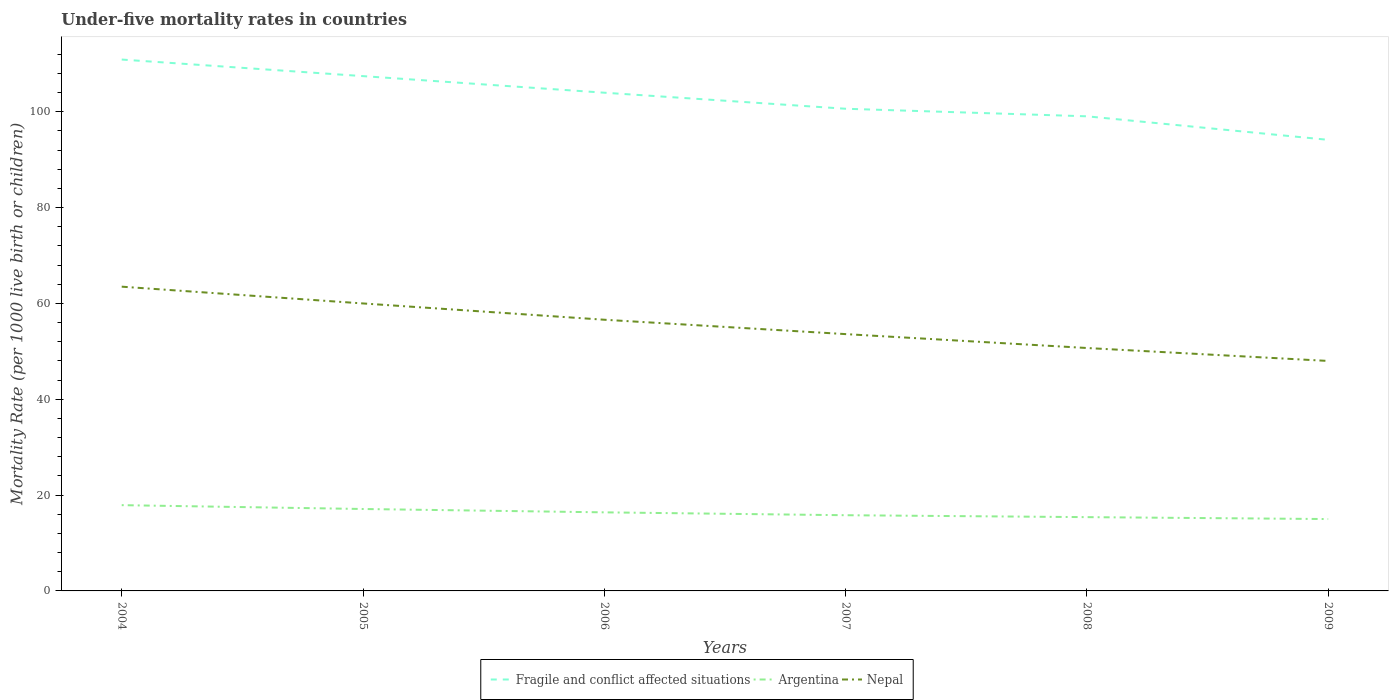How many different coloured lines are there?
Provide a succinct answer. 3. Does the line corresponding to Nepal intersect with the line corresponding to Fragile and conflict affected situations?
Provide a short and direct response. No. Is the number of lines equal to the number of legend labels?
Offer a very short reply. Yes. In which year was the under-five mortality rate in Argentina maximum?
Your response must be concise. 2009. What is the total under-five mortality rate in Argentina in the graph?
Keep it short and to the point. 1.7. What is the difference between the highest and the second highest under-five mortality rate in Fragile and conflict affected situations?
Offer a very short reply. 16.76. What is the difference between the highest and the lowest under-five mortality rate in Argentina?
Provide a succinct answer. 3. Is the under-five mortality rate in Fragile and conflict affected situations strictly greater than the under-five mortality rate in Nepal over the years?
Provide a short and direct response. No. What is the difference between two consecutive major ticks on the Y-axis?
Your answer should be compact. 20. Are the values on the major ticks of Y-axis written in scientific E-notation?
Keep it short and to the point. No. Does the graph contain any zero values?
Ensure brevity in your answer.  No. Does the graph contain grids?
Keep it short and to the point. No. Where does the legend appear in the graph?
Your response must be concise. Bottom center. How many legend labels are there?
Provide a succinct answer. 3. How are the legend labels stacked?
Your response must be concise. Horizontal. What is the title of the graph?
Offer a terse response. Under-five mortality rates in countries. What is the label or title of the X-axis?
Offer a terse response. Years. What is the label or title of the Y-axis?
Your response must be concise. Mortality Rate (per 1000 live birth or children). What is the Mortality Rate (per 1000 live birth or children) in Fragile and conflict affected situations in 2004?
Provide a succinct answer. 110.9. What is the Mortality Rate (per 1000 live birth or children) in Nepal in 2004?
Your answer should be very brief. 63.5. What is the Mortality Rate (per 1000 live birth or children) of Fragile and conflict affected situations in 2005?
Provide a short and direct response. 107.44. What is the Mortality Rate (per 1000 live birth or children) in Argentina in 2005?
Offer a terse response. 17.1. What is the Mortality Rate (per 1000 live birth or children) of Fragile and conflict affected situations in 2006?
Your answer should be very brief. 103.98. What is the Mortality Rate (per 1000 live birth or children) of Argentina in 2006?
Your answer should be compact. 16.4. What is the Mortality Rate (per 1000 live birth or children) of Nepal in 2006?
Keep it short and to the point. 56.6. What is the Mortality Rate (per 1000 live birth or children) of Fragile and conflict affected situations in 2007?
Provide a succinct answer. 100.64. What is the Mortality Rate (per 1000 live birth or children) of Argentina in 2007?
Provide a succinct answer. 15.8. What is the Mortality Rate (per 1000 live birth or children) of Nepal in 2007?
Offer a terse response. 53.6. What is the Mortality Rate (per 1000 live birth or children) of Fragile and conflict affected situations in 2008?
Provide a succinct answer. 99.06. What is the Mortality Rate (per 1000 live birth or children) of Argentina in 2008?
Your answer should be very brief. 15.4. What is the Mortality Rate (per 1000 live birth or children) in Nepal in 2008?
Offer a terse response. 50.7. What is the Mortality Rate (per 1000 live birth or children) in Fragile and conflict affected situations in 2009?
Your answer should be very brief. 94.15. What is the Mortality Rate (per 1000 live birth or children) in Nepal in 2009?
Provide a succinct answer. 48. Across all years, what is the maximum Mortality Rate (per 1000 live birth or children) in Fragile and conflict affected situations?
Your answer should be very brief. 110.9. Across all years, what is the maximum Mortality Rate (per 1000 live birth or children) in Nepal?
Give a very brief answer. 63.5. Across all years, what is the minimum Mortality Rate (per 1000 live birth or children) in Fragile and conflict affected situations?
Your answer should be compact. 94.15. What is the total Mortality Rate (per 1000 live birth or children) of Fragile and conflict affected situations in the graph?
Keep it short and to the point. 616.17. What is the total Mortality Rate (per 1000 live birth or children) of Argentina in the graph?
Ensure brevity in your answer.  97.6. What is the total Mortality Rate (per 1000 live birth or children) of Nepal in the graph?
Provide a short and direct response. 332.4. What is the difference between the Mortality Rate (per 1000 live birth or children) in Fragile and conflict affected situations in 2004 and that in 2005?
Offer a very short reply. 3.46. What is the difference between the Mortality Rate (per 1000 live birth or children) of Fragile and conflict affected situations in 2004 and that in 2006?
Keep it short and to the point. 6.92. What is the difference between the Mortality Rate (per 1000 live birth or children) of Argentina in 2004 and that in 2006?
Keep it short and to the point. 1.5. What is the difference between the Mortality Rate (per 1000 live birth or children) of Fragile and conflict affected situations in 2004 and that in 2007?
Keep it short and to the point. 10.27. What is the difference between the Mortality Rate (per 1000 live birth or children) of Fragile and conflict affected situations in 2004 and that in 2008?
Offer a very short reply. 11.85. What is the difference between the Mortality Rate (per 1000 live birth or children) in Argentina in 2004 and that in 2008?
Give a very brief answer. 2.5. What is the difference between the Mortality Rate (per 1000 live birth or children) of Nepal in 2004 and that in 2008?
Make the answer very short. 12.8. What is the difference between the Mortality Rate (per 1000 live birth or children) in Fragile and conflict affected situations in 2004 and that in 2009?
Offer a very short reply. 16.76. What is the difference between the Mortality Rate (per 1000 live birth or children) in Argentina in 2004 and that in 2009?
Give a very brief answer. 2.9. What is the difference between the Mortality Rate (per 1000 live birth or children) of Fragile and conflict affected situations in 2005 and that in 2006?
Your answer should be very brief. 3.46. What is the difference between the Mortality Rate (per 1000 live birth or children) of Argentina in 2005 and that in 2006?
Offer a terse response. 0.7. What is the difference between the Mortality Rate (per 1000 live birth or children) in Fragile and conflict affected situations in 2005 and that in 2007?
Offer a terse response. 6.81. What is the difference between the Mortality Rate (per 1000 live birth or children) in Fragile and conflict affected situations in 2005 and that in 2008?
Your response must be concise. 8.39. What is the difference between the Mortality Rate (per 1000 live birth or children) of Nepal in 2005 and that in 2008?
Offer a terse response. 9.3. What is the difference between the Mortality Rate (per 1000 live birth or children) in Fragile and conflict affected situations in 2005 and that in 2009?
Provide a succinct answer. 13.3. What is the difference between the Mortality Rate (per 1000 live birth or children) in Argentina in 2005 and that in 2009?
Provide a succinct answer. 2.1. What is the difference between the Mortality Rate (per 1000 live birth or children) in Nepal in 2005 and that in 2009?
Give a very brief answer. 12. What is the difference between the Mortality Rate (per 1000 live birth or children) in Fragile and conflict affected situations in 2006 and that in 2007?
Provide a succinct answer. 3.35. What is the difference between the Mortality Rate (per 1000 live birth or children) in Argentina in 2006 and that in 2007?
Offer a very short reply. 0.6. What is the difference between the Mortality Rate (per 1000 live birth or children) in Nepal in 2006 and that in 2007?
Your response must be concise. 3. What is the difference between the Mortality Rate (per 1000 live birth or children) of Fragile and conflict affected situations in 2006 and that in 2008?
Your answer should be compact. 4.93. What is the difference between the Mortality Rate (per 1000 live birth or children) of Fragile and conflict affected situations in 2006 and that in 2009?
Offer a terse response. 9.84. What is the difference between the Mortality Rate (per 1000 live birth or children) of Nepal in 2006 and that in 2009?
Your answer should be very brief. 8.6. What is the difference between the Mortality Rate (per 1000 live birth or children) in Fragile and conflict affected situations in 2007 and that in 2008?
Give a very brief answer. 1.58. What is the difference between the Mortality Rate (per 1000 live birth or children) of Nepal in 2007 and that in 2008?
Provide a short and direct response. 2.9. What is the difference between the Mortality Rate (per 1000 live birth or children) in Fragile and conflict affected situations in 2007 and that in 2009?
Offer a terse response. 6.49. What is the difference between the Mortality Rate (per 1000 live birth or children) of Argentina in 2007 and that in 2009?
Your response must be concise. 0.8. What is the difference between the Mortality Rate (per 1000 live birth or children) in Fragile and conflict affected situations in 2008 and that in 2009?
Offer a terse response. 4.91. What is the difference between the Mortality Rate (per 1000 live birth or children) of Fragile and conflict affected situations in 2004 and the Mortality Rate (per 1000 live birth or children) of Argentina in 2005?
Your response must be concise. 93.8. What is the difference between the Mortality Rate (per 1000 live birth or children) in Fragile and conflict affected situations in 2004 and the Mortality Rate (per 1000 live birth or children) in Nepal in 2005?
Keep it short and to the point. 50.9. What is the difference between the Mortality Rate (per 1000 live birth or children) of Argentina in 2004 and the Mortality Rate (per 1000 live birth or children) of Nepal in 2005?
Your answer should be compact. -42.1. What is the difference between the Mortality Rate (per 1000 live birth or children) of Fragile and conflict affected situations in 2004 and the Mortality Rate (per 1000 live birth or children) of Argentina in 2006?
Keep it short and to the point. 94.5. What is the difference between the Mortality Rate (per 1000 live birth or children) of Fragile and conflict affected situations in 2004 and the Mortality Rate (per 1000 live birth or children) of Nepal in 2006?
Provide a short and direct response. 54.3. What is the difference between the Mortality Rate (per 1000 live birth or children) of Argentina in 2004 and the Mortality Rate (per 1000 live birth or children) of Nepal in 2006?
Make the answer very short. -38.7. What is the difference between the Mortality Rate (per 1000 live birth or children) in Fragile and conflict affected situations in 2004 and the Mortality Rate (per 1000 live birth or children) in Argentina in 2007?
Offer a terse response. 95.1. What is the difference between the Mortality Rate (per 1000 live birth or children) in Fragile and conflict affected situations in 2004 and the Mortality Rate (per 1000 live birth or children) in Nepal in 2007?
Your answer should be very brief. 57.3. What is the difference between the Mortality Rate (per 1000 live birth or children) in Argentina in 2004 and the Mortality Rate (per 1000 live birth or children) in Nepal in 2007?
Ensure brevity in your answer.  -35.7. What is the difference between the Mortality Rate (per 1000 live birth or children) in Fragile and conflict affected situations in 2004 and the Mortality Rate (per 1000 live birth or children) in Argentina in 2008?
Make the answer very short. 95.5. What is the difference between the Mortality Rate (per 1000 live birth or children) in Fragile and conflict affected situations in 2004 and the Mortality Rate (per 1000 live birth or children) in Nepal in 2008?
Make the answer very short. 60.2. What is the difference between the Mortality Rate (per 1000 live birth or children) of Argentina in 2004 and the Mortality Rate (per 1000 live birth or children) of Nepal in 2008?
Make the answer very short. -32.8. What is the difference between the Mortality Rate (per 1000 live birth or children) in Fragile and conflict affected situations in 2004 and the Mortality Rate (per 1000 live birth or children) in Argentina in 2009?
Your response must be concise. 95.9. What is the difference between the Mortality Rate (per 1000 live birth or children) of Fragile and conflict affected situations in 2004 and the Mortality Rate (per 1000 live birth or children) of Nepal in 2009?
Keep it short and to the point. 62.9. What is the difference between the Mortality Rate (per 1000 live birth or children) in Argentina in 2004 and the Mortality Rate (per 1000 live birth or children) in Nepal in 2009?
Give a very brief answer. -30.1. What is the difference between the Mortality Rate (per 1000 live birth or children) in Fragile and conflict affected situations in 2005 and the Mortality Rate (per 1000 live birth or children) in Argentina in 2006?
Make the answer very short. 91.04. What is the difference between the Mortality Rate (per 1000 live birth or children) of Fragile and conflict affected situations in 2005 and the Mortality Rate (per 1000 live birth or children) of Nepal in 2006?
Keep it short and to the point. 50.84. What is the difference between the Mortality Rate (per 1000 live birth or children) of Argentina in 2005 and the Mortality Rate (per 1000 live birth or children) of Nepal in 2006?
Your answer should be compact. -39.5. What is the difference between the Mortality Rate (per 1000 live birth or children) of Fragile and conflict affected situations in 2005 and the Mortality Rate (per 1000 live birth or children) of Argentina in 2007?
Provide a short and direct response. 91.64. What is the difference between the Mortality Rate (per 1000 live birth or children) of Fragile and conflict affected situations in 2005 and the Mortality Rate (per 1000 live birth or children) of Nepal in 2007?
Provide a succinct answer. 53.84. What is the difference between the Mortality Rate (per 1000 live birth or children) of Argentina in 2005 and the Mortality Rate (per 1000 live birth or children) of Nepal in 2007?
Keep it short and to the point. -36.5. What is the difference between the Mortality Rate (per 1000 live birth or children) of Fragile and conflict affected situations in 2005 and the Mortality Rate (per 1000 live birth or children) of Argentina in 2008?
Ensure brevity in your answer.  92.04. What is the difference between the Mortality Rate (per 1000 live birth or children) of Fragile and conflict affected situations in 2005 and the Mortality Rate (per 1000 live birth or children) of Nepal in 2008?
Ensure brevity in your answer.  56.74. What is the difference between the Mortality Rate (per 1000 live birth or children) of Argentina in 2005 and the Mortality Rate (per 1000 live birth or children) of Nepal in 2008?
Make the answer very short. -33.6. What is the difference between the Mortality Rate (per 1000 live birth or children) of Fragile and conflict affected situations in 2005 and the Mortality Rate (per 1000 live birth or children) of Argentina in 2009?
Your answer should be very brief. 92.44. What is the difference between the Mortality Rate (per 1000 live birth or children) of Fragile and conflict affected situations in 2005 and the Mortality Rate (per 1000 live birth or children) of Nepal in 2009?
Your answer should be very brief. 59.44. What is the difference between the Mortality Rate (per 1000 live birth or children) in Argentina in 2005 and the Mortality Rate (per 1000 live birth or children) in Nepal in 2009?
Offer a very short reply. -30.9. What is the difference between the Mortality Rate (per 1000 live birth or children) of Fragile and conflict affected situations in 2006 and the Mortality Rate (per 1000 live birth or children) of Argentina in 2007?
Ensure brevity in your answer.  88.18. What is the difference between the Mortality Rate (per 1000 live birth or children) in Fragile and conflict affected situations in 2006 and the Mortality Rate (per 1000 live birth or children) in Nepal in 2007?
Your answer should be compact. 50.38. What is the difference between the Mortality Rate (per 1000 live birth or children) in Argentina in 2006 and the Mortality Rate (per 1000 live birth or children) in Nepal in 2007?
Your answer should be compact. -37.2. What is the difference between the Mortality Rate (per 1000 live birth or children) in Fragile and conflict affected situations in 2006 and the Mortality Rate (per 1000 live birth or children) in Argentina in 2008?
Ensure brevity in your answer.  88.58. What is the difference between the Mortality Rate (per 1000 live birth or children) in Fragile and conflict affected situations in 2006 and the Mortality Rate (per 1000 live birth or children) in Nepal in 2008?
Give a very brief answer. 53.28. What is the difference between the Mortality Rate (per 1000 live birth or children) of Argentina in 2006 and the Mortality Rate (per 1000 live birth or children) of Nepal in 2008?
Offer a terse response. -34.3. What is the difference between the Mortality Rate (per 1000 live birth or children) of Fragile and conflict affected situations in 2006 and the Mortality Rate (per 1000 live birth or children) of Argentina in 2009?
Make the answer very short. 88.98. What is the difference between the Mortality Rate (per 1000 live birth or children) of Fragile and conflict affected situations in 2006 and the Mortality Rate (per 1000 live birth or children) of Nepal in 2009?
Offer a terse response. 55.98. What is the difference between the Mortality Rate (per 1000 live birth or children) in Argentina in 2006 and the Mortality Rate (per 1000 live birth or children) in Nepal in 2009?
Ensure brevity in your answer.  -31.6. What is the difference between the Mortality Rate (per 1000 live birth or children) of Fragile and conflict affected situations in 2007 and the Mortality Rate (per 1000 live birth or children) of Argentina in 2008?
Keep it short and to the point. 85.24. What is the difference between the Mortality Rate (per 1000 live birth or children) in Fragile and conflict affected situations in 2007 and the Mortality Rate (per 1000 live birth or children) in Nepal in 2008?
Make the answer very short. 49.94. What is the difference between the Mortality Rate (per 1000 live birth or children) of Argentina in 2007 and the Mortality Rate (per 1000 live birth or children) of Nepal in 2008?
Your answer should be very brief. -34.9. What is the difference between the Mortality Rate (per 1000 live birth or children) in Fragile and conflict affected situations in 2007 and the Mortality Rate (per 1000 live birth or children) in Argentina in 2009?
Provide a succinct answer. 85.64. What is the difference between the Mortality Rate (per 1000 live birth or children) in Fragile and conflict affected situations in 2007 and the Mortality Rate (per 1000 live birth or children) in Nepal in 2009?
Your response must be concise. 52.64. What is the difference between the Mortality Rate (per 1000 live birth or children) in Argentina in 2007 and the Mortality Rate (per 1000 live birth or children) in Nepal in 2009?
Provide a short and direct response. -32.2. What is the difference between the Mortality Rate (per 1000 live birth or children) in Fragile and conflict affected situations in 2008 and the Mortality Rate (per 1000 live birth or children) in Argentina in 2009?
Your answer should be very brief. 84.06. What is the difference between the Mortality Rate (per 1000 live birth or children) of Fragile and conflict affected situations in 2008 and the Mortality Rate (per 1000 live birth or children) of Nepal in 2009?
Your answer should be very brief. 51.06. What is the difference between the Mortality Rate (per 1000 live birth or children) in Argentina in 2008 and the Mortality Rate (per 1000 live birth or children) in Nepal in 2009?
Make the answer very short. -32.6. What is the average Mortality Rate (per 1000 live birth or children) in Fragile and conflict affected situations per year?
Your answer should be compact. 102.7. What is the average Mortality Rate (per 1000 live birth or children) in Argentina per year?
Keep it short and to the point. 16.27. What is the average Mortality Rate (per 1000 live birth or children) of Nepal per year?
Your answer should be very brief. 55.4. In the year 2004, what is the difference between the Mortality Rate (per 1000 live birth or children) of Fragile and conflict affected situations and Mortality Rate (per 1000 live birth or children) of Argentina?
Provide a succinct answer. 93. In the year 2004, what is the difference between the Mortality Rate (per 1000 live birth or children) in Fragile and conflict affected situations and Mortality Rate (per 1000 live birth or children) in Nepal?
Offer a terse response. 47.4. In the year 2004, what is the difference between the Mortality Rate (per 1000 live birth or children) in Argentina and Mortality Rate (per 1000 live birth or children) in Nepal?
Offer a very short reply. -45.6. In the year 2005, what is the difference between the Mortality Rate (per 1000 live birth or children) of Fragile and conflict affected situations and Mortality Rate (per 1000 live birth or children) of Argentina?
Your response must be concise. 90.34. In the year 2005, what is the difference between the Mortality Rate (per 1000 live birth or children) in Fragile and conflict affected situations and Mortality Rate (per 1000 live birth or children) in Nepal?
Provide a succinct answer. 47.44. In the year 2005, what is the difference between the Mortality Rate (per 1000 live birth or children) of Argentina and Mortality Rate (per 1000 live birth or children) of Nepal?
Provide a succinct answer. -42.9. In the year 2006, what is the difference between the Mortality Rate (per 1000 live birth or children) in Fragile and conflict affected situations and Mortality Rate (per 1000 live birth or children) in Argentina?
Your response must be concise. 87.58. In the year 2006, what is the difference between the Mortality Rate (per 1000 live birth or children) in Fragile and conflict affected situations and Mortality Rate (per 1000 live birth or children) in Nepal?
Your answer should be compact. 47.38. In the year 2006, what is the difference between the Mortality Rate (per 1000 live birth or children) in Argentina and Mortality Rate (per 1000 live birth or children) in Nepal?
Provide a succinct answer. -40.2. In the year 2007, what is the difference between the Mortality Rate (per 1000 live birth or children) of Fragile and conflict affected situations and Mortality Rate (per 1000 live birth or children) of Argentina?
Give a very brief answer. 84.84. In the year 2007, what is the difference between the Mortality Rate (per 1000 live birth or children) of Fragile and conflict affected situations and Mortality Rate (per 1000 live birth or children) of Nepal?
Your answer should be compact. 47.04. In the year 2007, what is the difference between the Mortality Rate (per 1000 live birth or children) of Argentina and Mortality Rate (per 1000 live birth or children) of Nepal?
Offer a terse response. -37.8. In the year 2008, what is the difference between the Mortality Rate (per 1000 live birth or children) in Fragile and conflict affected situations and Mortality Rate (per 1000 live birth or children) in Argentina?
Your response must be concise. 83.66. In the year 2008, what is the difference between the Mortality Rate (per 1000 live birth or children) of Fragile and conflict affected situations and Mortality Rate (per 1000 live birth or children) of Nepal?
Your answer should be compact. 48.36. In the year 2008, what is the difference between the Mortality Rate (per 1000 live birth or children) in Argentina and Mortality Rate (per 1000 live birth or children) in Nepal?
Offer a terse response. -35.3. In the year 2009, what is the difference between the Mortality Rate (per 1000 live birth or children) in Fragile and conflict affected situations and Mortality Rate (per 1000 live birth or children) in Argentina?
Offer a very short reply. 79.15. In the year 2009, what is the difference between the Mortality Rate (per 1000 live birth or children) in Fragile and conflict affected situations and Mortality Rate (per 1000 live birth or children) in Nepal?
Provide a succinct answer. 46.15. In the year 2009, what is the difference between the Mortality Rate (per 1000 live birth or children) of Argentina and Mortality Rate (per 1000 live birth or children) of Nepal?
Your answer should be very brief. -33. What is the ratio of the Mortality Rate (per 1000 live birth or children) in Fragile and conflict affected situations in 2004 to that in 2005?
Ensure brevity in your answer.  1.03. What is the ratio of the Mortality Rate (per 1000 live birth or children) of Argentina in 2004 to that in 2005?
Give a very brief answer. 1.05. What is the ratio of the Mortality Rate (per 1000 live birth or children) of Nepal in 2004 to that in 2005?
Your response must be concise. 1.06. What is the ratio of the Mortality Rate (per 1000 live birth or children) in Fragile and conflict affected situations in 2004 to that in 2006?
Offer a very short reply. 1.07. What is the ratio of the Mortality Rate (per 1000 live birth or children) of Argentina in 2004 to that in 2006?
Ensure brevity in your answer.  1.09. What is the ratio of the Mortality Rate (per 1000 live birth or children) of Nepal in 2004 to that in 2006?
Your answer should be compact. 1.12. What is the ratio of the Mortality Rate (per 1000 live birth or children) of Fragile and conflict affected situations in 2004 to that in 2007?
Your response must be concise. 1.1. What is the ratio of the Mortality Rate (per 1000 live birth or children) in Argentina in 2004 to that in 2007?
Your response must be concise. 1.13. What is the ratio of the Mortality Rate (per 1000 live birth or children) in Nepal in 2004 to that in 2007?
Offer a very short reply. 1.18. What is the ratio of the Mortality Rate (per 1000 live birth or children) of Fragile and conflict affected situations in 2004 to that in 2008?
Provide a succinct answer. 1.12. What is the ratio of the Mortality Rate (per 1000 live birth or children) of Argentina in 2004 to that in 2008?
Your answer should be compact. 1.16. What is the ratio of the Mortality Rate (per 1000 live birth or children) of Nepal in 2004 to that in 2008?
Offer a terse response. 1.25. What is the ratio of the Mortality Rate (per 1000 live birth or children) in Fragile and conflict affected situations in 2004 to that in 2009?
Provide a short and direct response. 1.18. What is the ratio of the Mortality Rate (per 1000 live birth or children) in Argentina in 2004 to that in 2009?
Your response must be concise. 1.19. What is the ratio of the Mortality Rate (per 1000 live birth or children) in Nepal in 2004 to that in 2009?
Give a very brief answer. 1.32. What is the ratio of the Mortality Rate (per 1000 live birth or children) in Argentina in 2005 to that in 2006?
Give a very brief answer. 1.04. What is the ratio of the Mortality Rate (per 1000 live birth or children) of Nepal in 2005 to that in 2006?
Give a very brief answer. 1.06. What is the ratio of the Mortality Rate (per 1000 live birth or children) in Fragile and conflict affected situations in 2005 to that in 2007?
Make the answer very short. 1.07. What is the ratio of the Mortality Rate (per 1000 live birth or children) in Argentina in 2005 to that in 2007?
Your answer should be compact. 1.08. What is the ratio of the Mortality Rate (per 1000 live birth or children) of Nepal in 2005 to that in 2007?
Keep it short and to the point. 1.12. What is the ratio of the Mortality Rate (per 1000 live birth or children) of Fragile and conflict affected situations in 2005 to that in 2008?
Make the answer very short. 1.08. What is the ratio of the Mortality Rate (per 1000 live birth or children) in Argentina in 2005 to that in 2008?
Make the answer very short. 1.11. What is the ratio of the Mortality Rate (per 1000 live birth or children) in Nepal in 2005 to that in 2008?
Keep it short and to the point. 1.18. What is the ratio of the Mortality Rate (per 1000 live birth or children) of Fragile and conflict affected situations in 2005 to that in 2009?
Your response must be concise. 1.14. What is the ratio of the Mortality Rate (per 1000 live birth or children) of Argentina in 2005 to that in 2009?
Your response must be concise. 1.14. What is the ratio of the Mortality Rate (per 1000 live birth or children) in Nepal in 2005 to that in 2009?
Make the answer very short. 1.25. What is the ratio of the Mortality Rate (per 1000 live birth or children) of Argentina in 2006 to that in 2007?
Offer a terse response. 1.04. What is the ratio of the Mortality Rate (per 1000 live birth or children) in Nepal in 2006 to that in 2007?
Your response must be concise. 1.06. What is the ratio of the Mortality Rate (per 1000 live birth or children) in Fragile and conflict affected situations in 2006 to that in 2008?
Offer a terse response. 1.05. What is the ratio of the Mortality Rate (per 1000 live birth or children) of Argentina in 2006 to that in 2008?
Make the answer very short. 1.06. What is the ratio of the Mortality Rate (per 1000 live birth or children) of Nepal in 2006 to that in 2008?
Provide a short and direct response. 1.12. What is the ratio of the Mortality Rate (per 1000 live birth or children) of Fragile and conflict affected situations in 2006 to that in 2009?
Keep it short and to the point. 1.1. What is the ratio of the Mortality Rate (per 1000 live birth or children) of Argentina in 2006 to that in 2009?
Your answer should be very brief. 1.09. What is the ratio of the Mortality Rate (per 1000 live birth or children) in Nepal in 2006 to that in 2009?
Give a very brief answer. 1.18. What is the ratio of the Mortality Rate (per 1000 live birth or children) of Fragile and conflict affected situations in 2007 to that in 2008?
Offer a very short reply. 1.02. What is the ratio of the Mortality Rate (per 1000 live birth or children) of Nepal in 2007 to that in 2008?
Your answer should be very brief. 1.06. What is the ratio of the Mortality Rate (per 1000 live birth or children) in Fragile and conflict affected situations in 2007 to that in 2009?
Ensure brevity in your answer.  1.07. What is the ratio of the Mortality Rate (per 1000 live birth or children) in Argentina in 2007 to that in 2009?
Your answer should be very brief. 1.05. What is the ratio of the Mortality Rate (per 1000 live birth or children) of Nepal in 2007 to that in 2009?
Keep it short and to the point. 1.12. What is the ratio of the Mortality Rate (per 1000 live birth or children) in Fragile and conflict affected situations in 2008 to that in 2009?
Provide a short and direct response. 1.05. What is the ratio of the Mortality Rate (per 1000 live birth or children) of Argentina in 2008 to that in 2009?
Your response must be concise. 1.03. What is the ratio of the Mortality Rate (per 1000 live birth or children) in Nepal in 2008 to that in 2009?
Make the answer very short. 1.06. What is the difference between the highest and the second highest Mortality Rate (per 1000 live birth or children) in Fragile and conflict affected situations?
Keep it short and to the point. 3.46. What is the difference between the highest and the second highest Mortality Rate (per 1000 live birth or children) in Argentina?
Your response must be concise. 0.8. What is the difference between the highest and the second highest Mortality Rate (per 1000 live birth or children) in Nepal?
Offer a very short reply. 3.5. What is the difference between the highest and the lowest Mortality Rate (per 1000 live birth or children) of Fragile and conflict affected situations?
Give a very brief answer. 16.76. What is the difference between the highest and the lowest Mortality Rate (per 1000 live birth or children) of Argentina?
Provide a short and direct response. 2.9. 